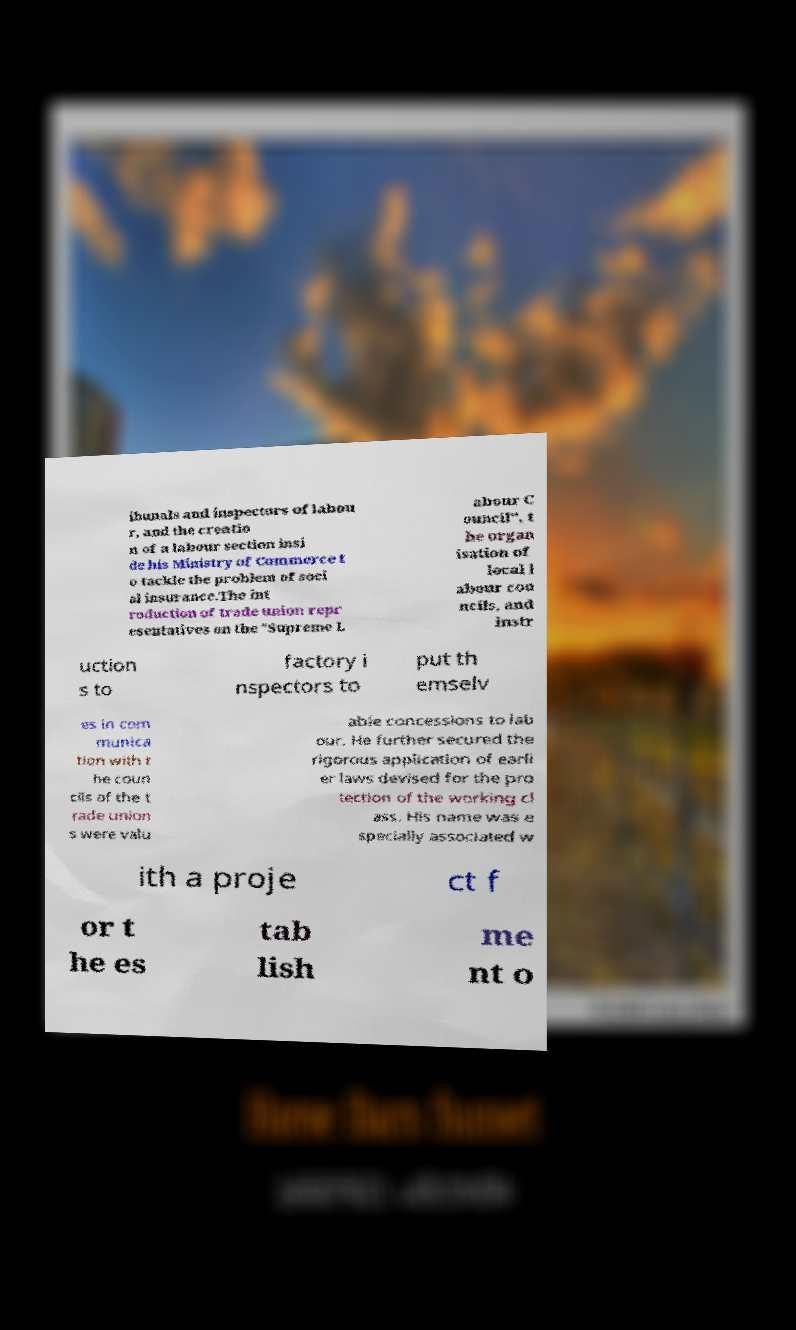Can you read and provide the text displayed in the image?This photo seems to have some interesting text. Can you extract and type it out for me? ibunals and inspectors of labou r, and the creatio n of a labour section insi de his Ministry of Commerce t o tackle the problem of soci al insurance.The int roduction of trade union repr esentatives on the "Supreme L abour C ouncil", t he organ isation of local l abour cou ncils, and instr uction s to factory i nspectors to put th emselv es in com munica tion with t he coun cils of the t rade union s were valu able concessions to lab our. He further secured the rigorous application of earli er laws devised for the pro tection of the working cl ass. His name was e specially associated w ith a proje ct f or t he es tab lish me nt o 